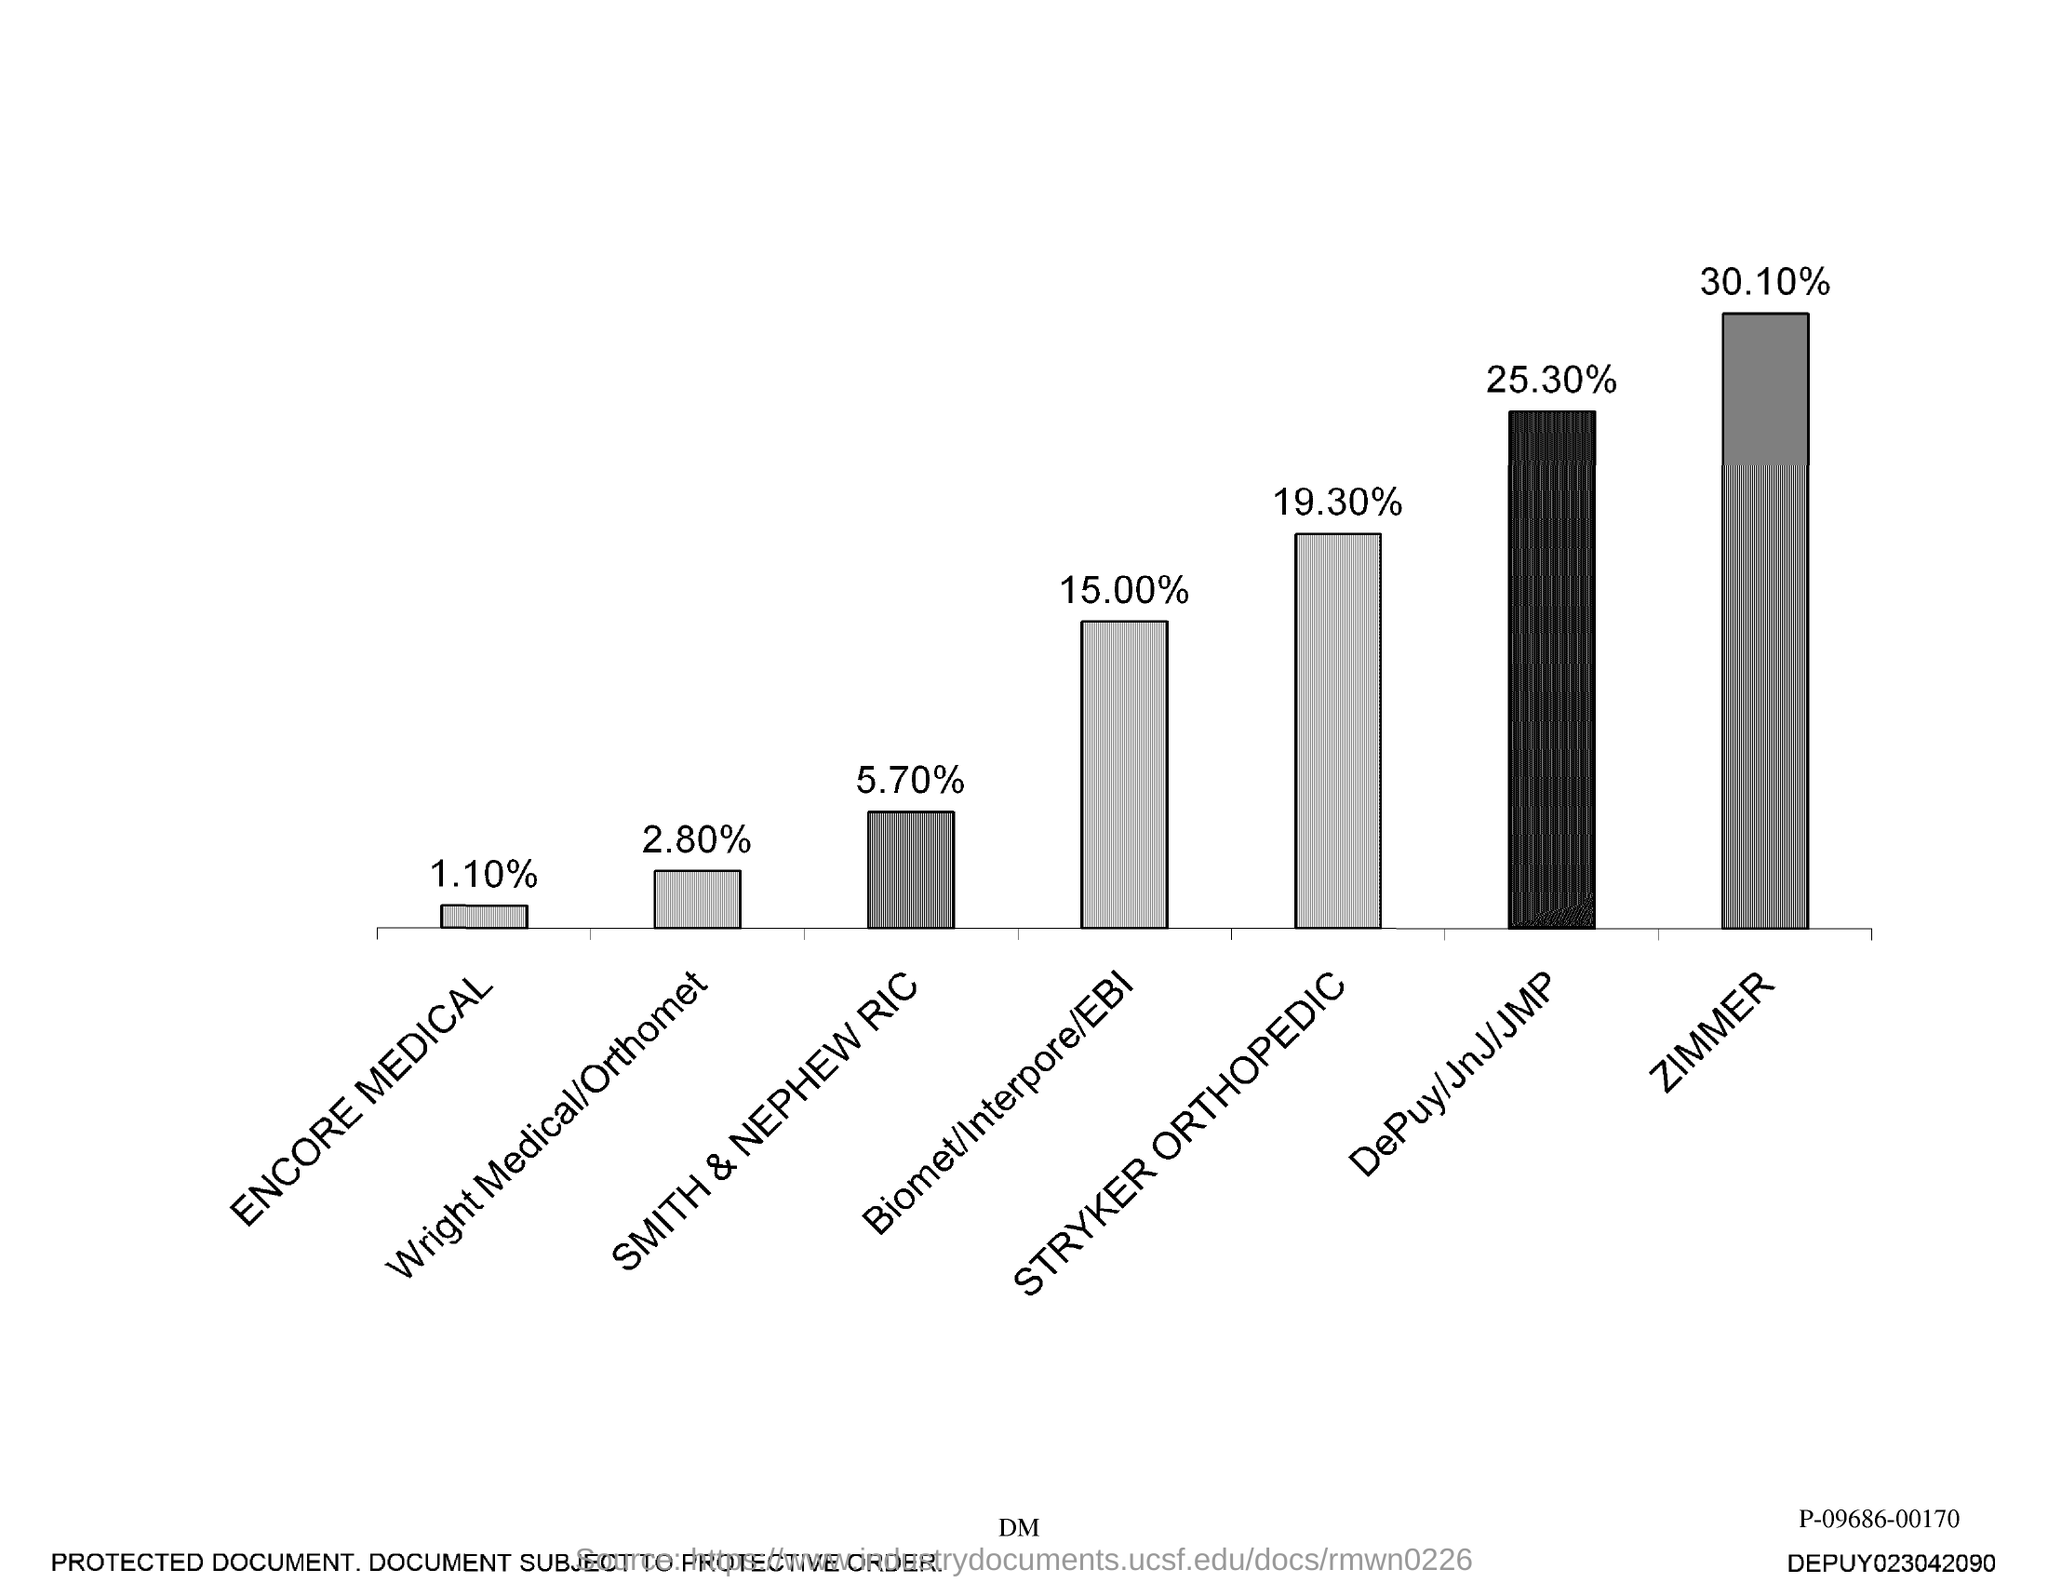The lowest value shown in the graph?
Your answer should be compact. 1.10%. The highest value shown in the graph?
Your response must be concise. 30.10%. 